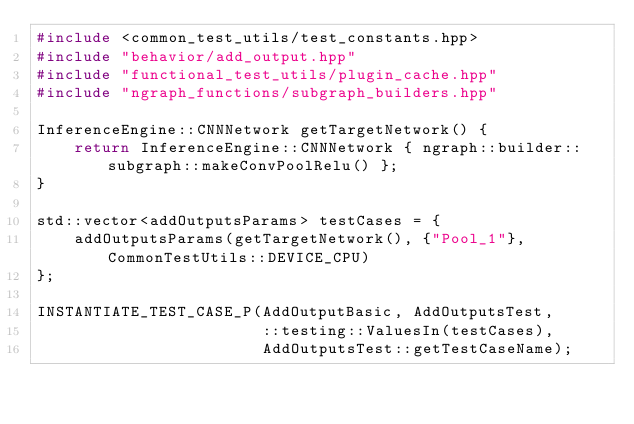<code> <loc_0><loc_0><loc_500><loc_500><_C++_>#include <common_test_utils/test_constants.hpp>
#include "behavior/add_output.hpp"
#include "functional_test_utils/plugin_cache.hpp"
#include "ngraph_functions/subgraph_builders.hpp"

InferenceEngine::CNNNetwork getTargetNetwork() {
    return InferenceEngine::CNNNetwork { ngraph::builder::subgraph::makeConvPoolRelu() };
}

std::vector<addOutputsParams> testCases = {
    addOutputsParams(getTargetNetwork(), {"Pool_1"}, CommonTestUtils::DEVICE_CPU)
};

INSTANTIATE_TEST_CASE_P(AddOutputBasic, AddOutputsTest,
                        ::testing::ValuesIn(testCases),
                        AddOutputsTest::getTestCaseName);
</code> 